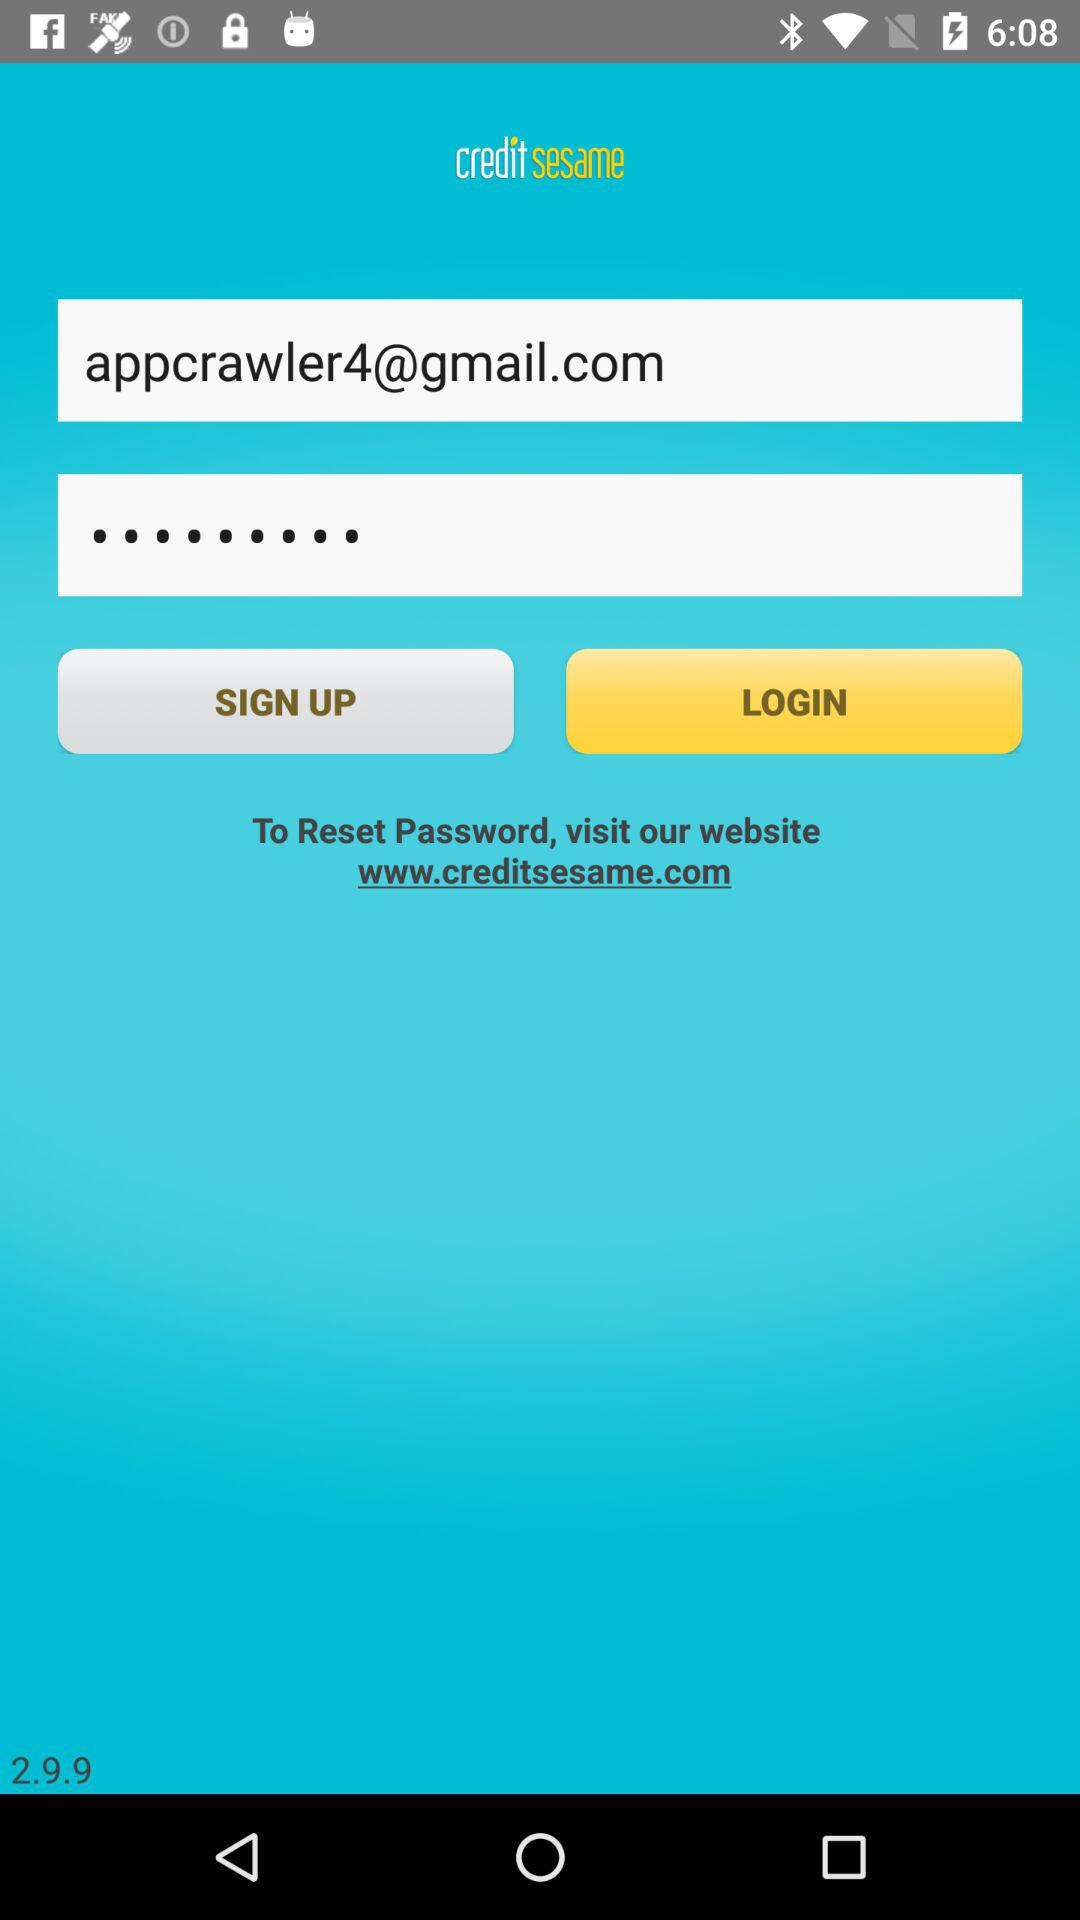What is the application name? The application name is "credit sesame". 